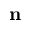<formula> <loc_0><loc_0><loc_500><loc_500>n</formula> 